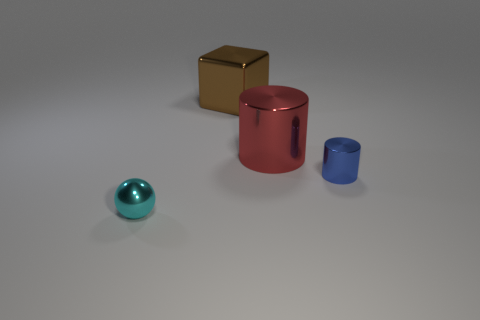How would you describe the lighting in this scene? The lighting in the scene is soft and diffused, coming from a direction that casts gentle shadows on the right side of the objects, suggesting a single light source. 